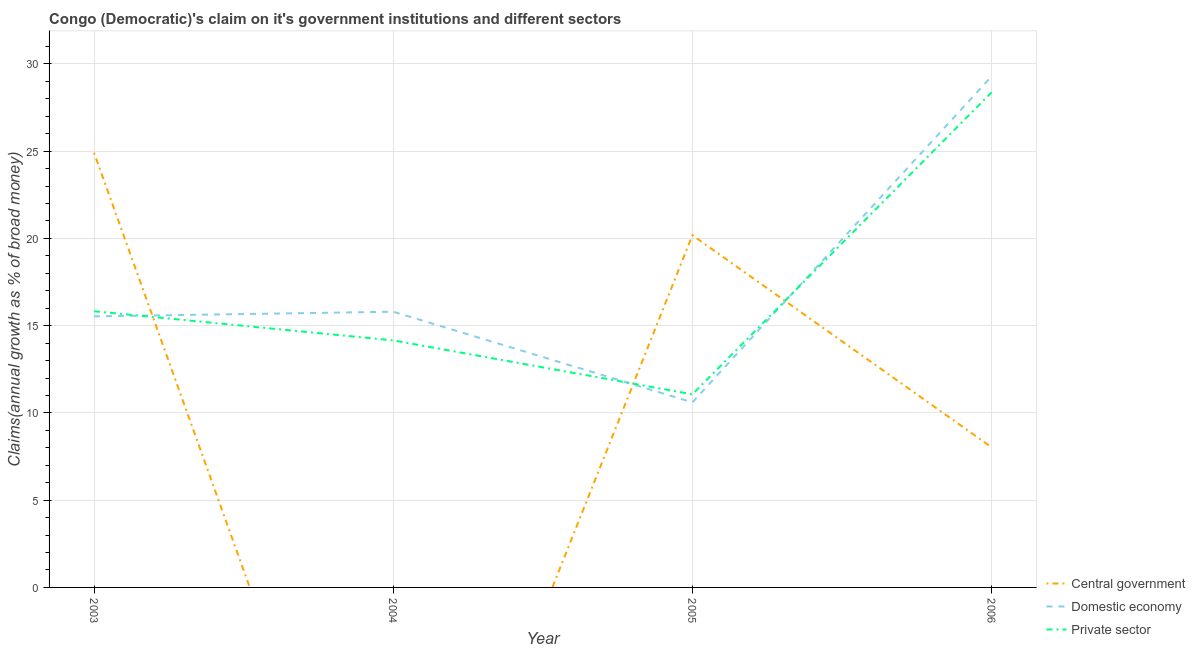Does the line corresponding to percentage of claim on the central government intersect with the line corresponding to percentage of claim on the private sector?
Your response must be concise. Yes. Is the number of lines equal to the number of legend labels?
Your response must be concise. No. What is the percentage of claim on the domestic economy in 2006?
Keep it short and to the point. 29.29. Across all years, what is the maximum percentage of claim on the private sector?
Keep it short and to the point. 28.37. Across all years, what is the minimum percentage of claim on the private sector?
Your answer should be compact. 11.07. In which year was the percentage of claim on the private sector maximum?
Keep it short and to the point. 2006. What is the total percentage of claim on the central government in the graph?
Provide a short and direct response. 53.13. What is the difference between the percentage of claim on the private sector in 2004 and that in 2005?
Keep it short and to the point. 3.09. What is the difference between the percentage of claim on the central government in 2004 and the percentage of claim on the private sector in 2005?
Provide a succinct answer. -11.07. What is the average percentage of claim on the private sector per year?
Your answer should be very brief. 17.36. In the year 2004, what is the difference between the percentage of claim on the domestic economy and percentage of claim on the private sector?
Your answer should be very brief. 1.64. In how many years, is the percentage of claim on the private sector greater than 25 %?
Offer a very short reply. 1. What is the ratio of the percentage of claim on the private sector in 2004 to that in 2005?
Offer a terse response. 1.28. Is the percentage of claim on the private sector in 2004 less than that in 2005?
Your answer should be compact. No. What is the difference between the highest and the second highest percentage of claim on the domestic economy?
Your answer should be very brief. 13.49. What is the difference between the highest and the lowest percentage of claim on the private sector?
Keep it short and to the point. 17.31. In how many years, is the percentage of claim on the domestic economy greater than the average percentage of claim on the domestic economy taken over all years?
Give a very brief answer. 1. Is the sum of the percentage of claim on the private sector in 2003 and 2006 greater than the maximum percentage of claim on the central government across all years?
Your answer should be very brief. Yes. Is the percentage of claim on the domestic economy strictly less than the percentage of claim on the private sector over the years?
Your answer should be very brief. No. How many years are there in the graph?
Your response must be concise. 4. Does the graph contain any zero values?
Offer a very short reply. Yes. Does the graph contain grids?
Provide a short and direct response. Yes. How are the legend labels stacked?
Your response must be concise. Vertical. What is the title of the graph?
Keep it short and to the point. Congo (Democratic)'s claim on it's government institutions and different sectors. What is the label or title of the Y-axis?
Ensure brevity in your answer.  Claims(annual growth as % of broad money). What is the Claims(annual growth as % of broad money) in Central government in 2003?
Give a very brief answer. 24.91. What is the Claims(annual growth as % of broad money) in Domestic economy in 2003?
Give a very brief answer. 15.53. What is the Claims(annual growth as % of broad money) of Private sector in 2003?
Provide a short and direct response. 15.83. What is the Claims(annual growth as % of broad money) of Domestic economy in 2004?
Provide a short and direct response. 15.8. What is the Claims(annual growth as % of broad money) of Private sector in 2004?
Provide a short and direct response. 14.16. What is the Claims(annual growth as % of broad money) of Central government in 2005?
Provide a short and direct response. 20.18. What is the Claims(annual growth as % of broad money) in Domestic economy in 2005?
Your answer should be compact. 10.61. What is the Claims(annual growth as % of broad money) in Private sector in 2005?
Keep it short and to the point. 11.07. What is the Claims(annual growth as % of broad money) of Central government in 2006?
Ensure brevity in your answer.  8.03. What is the Claims(annual growth as % of broad money) in Domestic economy in 2006?
Ensure brevity in your answer.  29.29. What is the Claims(annual growth as % of broad money) in Private sector in 2006?
Make the answer very short. 28.37. Across all years, what is the maximum Claims(annual growth as % of broad money) in Central government?
Your response must be concise. 24.91. Across all years, what is the maximum Claims(annual growth as % of broad money) in Domestic economy?
Provide a short and direct response. 29.29. Across all years, what is the maximum Claims(annual growth as % of broad money) in Private sector?
Give a very brief answer. 28.37. Across all years, what is the minimum Claims(annual growth as % of broad money) of Domestic economy?
Your answer should be compact. 10.61. Across all years, what is the minimum Claims(annual growth as % of broad money) in Private sector?
Keep it short and to the point. 11.07. What is the total Claims(annual growth as % of broad money) in Central government in the graph?
Ensure brevity in your answer.  53.13. What is the total Claims(annual growth as % of broad money) of Domestic economy in the graph?
Offer a terse response. 71.23. What is the total Claims(annual growth as % of broad money) in Private sector in the graph?
Provide a succinct answer. 69.42. What is the difference between the Claims(annual growth as % of broad money) of Domestic economy in 2003 and that in 2004?
Offer a very short reply. -0.27. What is the difference between the Claims(annual growth as % of broad money) in Private sector in 2003 and that in 2004?
Your answer should be compact. 1.67. What is the difference between the Claims(annual growth as % of broad money) of Central government in 2003 and that in 2005?
Your answer should be very brief. 4.73. What is the difference between the Claims(annual growth as % of broad money) in Domestic economy in 2003 and that in 2005?
Provide a succinct answer. 4.93. What is the difference between the Claims(annual growth as % of broad money) in Private sector in 2003 and that in 2005?
Keep it short and to the point. 4.76. What is the difference between the Claims(annual growth as % of broad money) of Central government in 2003 and that in 2006?
Give a very brief answer. 16.89. What is the difference between the Claims(annual growth as % of broad money) of Domestic economy in 2003 and that in 2006?
Provide a succinct answer. -13.75. What is the difference between the Claims(annual growth as % of broad money) in Private sector in 2003 and that in 2006?
Your answer should be very brief. -12.55. What is the difference between the Claims(annual growth as % of broad money) in Domestic economy in 2004 and that in 2005?
Make the answer very short. 5.19. What is the difference between the Claims(annual growth as % of broad money) of Private sector in 2004 and that in 2005?
Ensure brevity in your answer.  3.09. What is the difference between the Claims(annual growth as % of broad money) of Domestic economy in 2004 and that in 2006?
Your answer should be compact. -13.49. What is the difference between the Claims(annual growth as % of broad money) in Private sector in 2004 and that in 2006?
Your response must be concise. -14.22. What is the difference between the Claims(annual growth as % of broad money) of Central government in 2005 and that in 2006?
Ensure brevity in your answer.  12.16. What is the difference between the Claims(annual growth as % of broad money) in Domestic economy in 2005 and that in 2006?
Your answer should be very brief. -18.68. What is the difference between the Claims(annual growth as % of broad money) of Private sector in 2005 and that in 2006?
Provide a succinct answer. -17.31. What is the difference between the Claims(annual growth as % of broad money) in Central government in 2003 and the Claims(annual growth as % of broad money) in Domestic economy in 2004?
Give a very brief answer. 9.11. What is the difference between the Claims(annual growth as % of broad money) in Central government in 2003 and the Claims(annual growth as % of broad money) in Private sector in 2004?
Ensure brevity in your answer.  10.76. What is the difference between the Claims(annual growth as % of broad money) of Domestic economy in 2003 and the Claims(annual growth as % of broad money) of Private sector in 2004?
Provide a succinct answer. 1.38. What is the difference between the Claims(annual growth as % of broad money) of Central government in 2003 and the Claims(annual growth as % of broad money) of Domestic economy in 2005?
Your answer should be compact. 14.31. What is the difference between the Claims(annual growth as % of broad money) of Central government in 2003 and the Claims(annual growth as % of broad money) of Private sector in 2005?
Offer a very short reply. 13.85. What is the difference between the Claims(annual growth as % of broad money) in Domestic economy in 2003 and the Claims(annual growth as % of broad money) in Private sector in 2005?
Keep it short and to the point. 4.47. What is the difference between the Claims(annual growth as % of broad money) in Central government in 2003 and the Claims(annual growth as % of broad money) in Domestic economy in 2006?
Ensure brevity in your answer.  -4.37. What is the difference between the Claims(annual growth as % of broad money) in Central government in 2003 and the Claims(annual growth as % of broad money) in Private sector in 2006?
Your response must be concise. -3.46. What is the difference between the Claims(annual growth as % of broad money) in Domestic economy in 2003 and the Claims(annual growth as % of broad money) in Private sector in 2006?
Your answer should be compact. -12.84. What is the difference between the Claims(annual growth as % of broad money) of Domestic economy in 2004 and the Claims(annual growth as % of broad money) of Private sector in 2005?
Ensure brevity in your answer.  4.73. What is the difference between the Claims(annual growth as % of broad money) of Domestic economy in 2004 and the Claims(annual growth as % of broad money) of Private sector in 2006?
Make the answer very short. -12.57. What is the difference between the Claims(annual growth as % of broad money) of Central government in 2005 and the Claims(annual growth as % of broad money) of Domestic economy in 2006?
Keep it short and to the point. -9.1. What is the difference between the Claims(annual growth as % of broad money) of Central government in 2005 and the Claims(annual growth as % of broad money) of Private sector in 2006?
Provide a succinct answer. -8.19. What is the difference between the Claims(annual growth as % of broad money) in Domestic economy in 2005 and the Claims(annual growth as % of broad money) in Private sector in 2006?
Your answer should be very brief. -17.77. What is the average Claims(annual growth as % of broad money) in Central government per year?
Offer a very short reply. 13.28. What is the average Claims(annual growth as % of broad money) of Domestic economy per year?
Give a very brief answer. 17.81. What is the average Claims(annual growth as % of broad money) of Private sector per year?
Give a very brief answer. 17.36. In the year 2003, what is the difference between the Claims(annual growth as % of broad money) in Central government and Claims(annual growth as % of broad money) in Domestic economy?
Give a very brief answer. 9.38. In the year 2003, what is the difference between the Claims(annual growth as % of broad money) in Central government and Claims(annual growth as % of broad money) in Private sector?
Give a very brief answer. 9.09. In the year 2003, what is the difference between the Claims(annual growth as % of broad money) in Domestic economy and Claims(annual growth as % of broad money) in Private sector?
Your answer should be very brief. -0.29. In the year 2004, what is the difference between the Claims(annual growth as % of broad money) of Domestic economy and Claims(annual growth as % of broad money) of Private sector?
Provide a succinct answer. 1.64. In the year 2005, what is the difference between the Claims(annual growth as % of broad money) in Central government and Claims(annual growth as % of broad money) in Domestic economy?
Give a very brief answer. 9.58. In the year 2005, what is the difference between the Claims(annual growth as % of broad money) in Central government and Claims(annual growth as % of broad money) in Private sector?
Your answer should be very brief. 9.12. In the year 2005, what is the difference between the Claims(annual growth as % of broad money) in Domestic economy and Claims(annual growth as % of broad money) in Private sector?
Make the answer very short. -0.46. In the year 2006, what is the difference between the Claims(annual growth as % of broad money) of Central government and Claims(annual growth as % of broad money) of Domestic economy?
Offer a very short reply. -21.26. In the year 2006, what is the difference between the Claims(annual growth as % of broad money) of Central government and Claims(annual growth as % of broad money) of Private sector?
Ensure brevity in your answer.  -20.35. In the year 2006, what is the difference between the Claims(annual growth as % of broad money) in Domestic economy and Claims(annual growth as % of broad money) in Private sector?
Your response must be concise. 0.91. What is the ratio of the Claims(annual growth as % of broad money) in Domestic economy in 2003 to that in 2004?
Your response must be concise. 0.98. What is the ratio of the Claims(annual growth as % of broad money) of Private sector in 2003 to that in 2004?
Keep it short and to the point. 1.12. What is the ratio of the Claims(annual growth as % of broad money) of Central government in 2003 to that in 2005?
Provide a succinct answer. 1.23. What is the ratio of the Claims(annual growth as % of broad money) of Domestic economy in 2003 to that in 2005?
Offer a terse response. 1.46. What is the ratio of the Claims(annual growth as % of broad money) of Private sector in 2003 to that in 2005?
Make the answer very short. 1.43. What is the ratio of the Claims(annual growth as % of broad money) of Central government in 2003 to that in 2006?
Make the answer very short. 3.1. What is the ratio of the Claims(annual growth as % of broad money) in Domestic economy in 2003 to that in 2006?
Your answer should be compact. 0.53. What is the ratio of the Claims(annual growth as % of broad money) of Private sector in 2003 to that in 2006?
Give a very brief answer. 0.56. What is the ratio of the Claims(annual growth as % of broad money) in Domestic economy in 2004 to that in 2005?
Offer a terse response. 1.49. What is the ratio of the Claims(annual growth as % of broad money) in Private sector in 2004 to that in 2005?
Your response must be concise. 1.28. What is the ratio of the Claims(annual growth as % of broad money) of Domestic economy in 2004 to that in 2006?
Keep it short and to the point. 0.54. What is the ratio of the Claims(annual growth as % of broad money) of Private sector in 2004 to that in 2006?
Ensure brevity in your answer.  0.5. What is the ratio of the Claims(annual growth as % of broad money) of Central government in 2005 to that in 2006?
Provide a short and direct response. 2.51. What is the ratio of the Claims(annual growth as % of broad money) of Domestic economy in 2005 to that in 2006?
Your answer should be very brief. 0.36. What is the ratio of the Claims(annual growth as % of broad money) in Private sector in 2005 to that in 2006?
Ensure brevity in your answer.  0.39. What is the difference between the highest and the second highest Claims(annual growth as % of broad money) of Central government?
Keep it short and to the point. 4.73. What is the difference between the highest and the second highest Claims(annual growth as % of broad money) of Domestic economy?
Give a very brief answer. 13.49. What is the difference between the highest and the second highest Claims(annual growth as % of broad money) of Private sector?
Offer a terse response. 12.55. What is the difference between the highest and the lowest Claims(annual growth as % of broad money) of Central government?
Make the answer very short. 24.91. What is the difference between the highest and the lowest Claims(annual growth as % of broad money) in Domestic economy?
Your answer should be compact. 18.68. What is the difference between the highest and the lowest Claims(annual growth as % of broad money) of Private sector?
Your answer should be very brief. 17.31. 